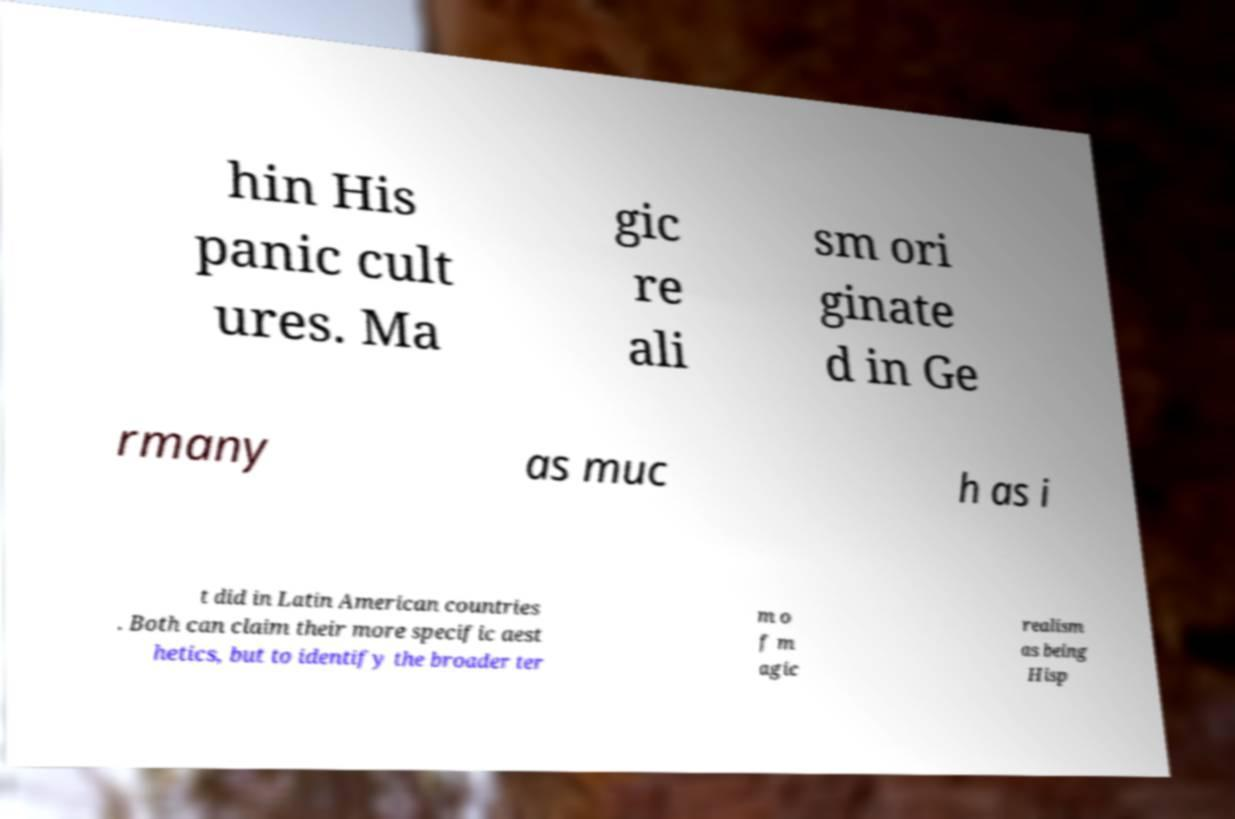Could you extract and type out the text from this image? hin His panic cult ures. Ma gic re ali sm ori ginate d in Ge rmany as muc h as i t did in Latin American countries . Both can claim their more specific aest hetics, but to identify the broader ter m o f m agic realism as being Hisp 